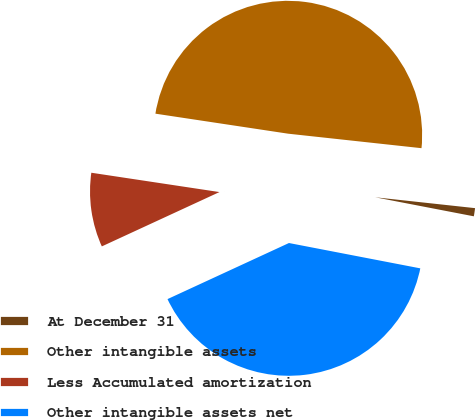Convert chart. <chart><loc_0><loc_0><loc_500><loc_500><pie_chart><fcel>At December 31<fcel>Other intangible assets<fcel>Less Accumulated amortization<fcel>Other intangible assets net<nl><fcel>1.31%<fcel>49.34%<fcel>9.27%<fcel>40.08%<nl></chart> 